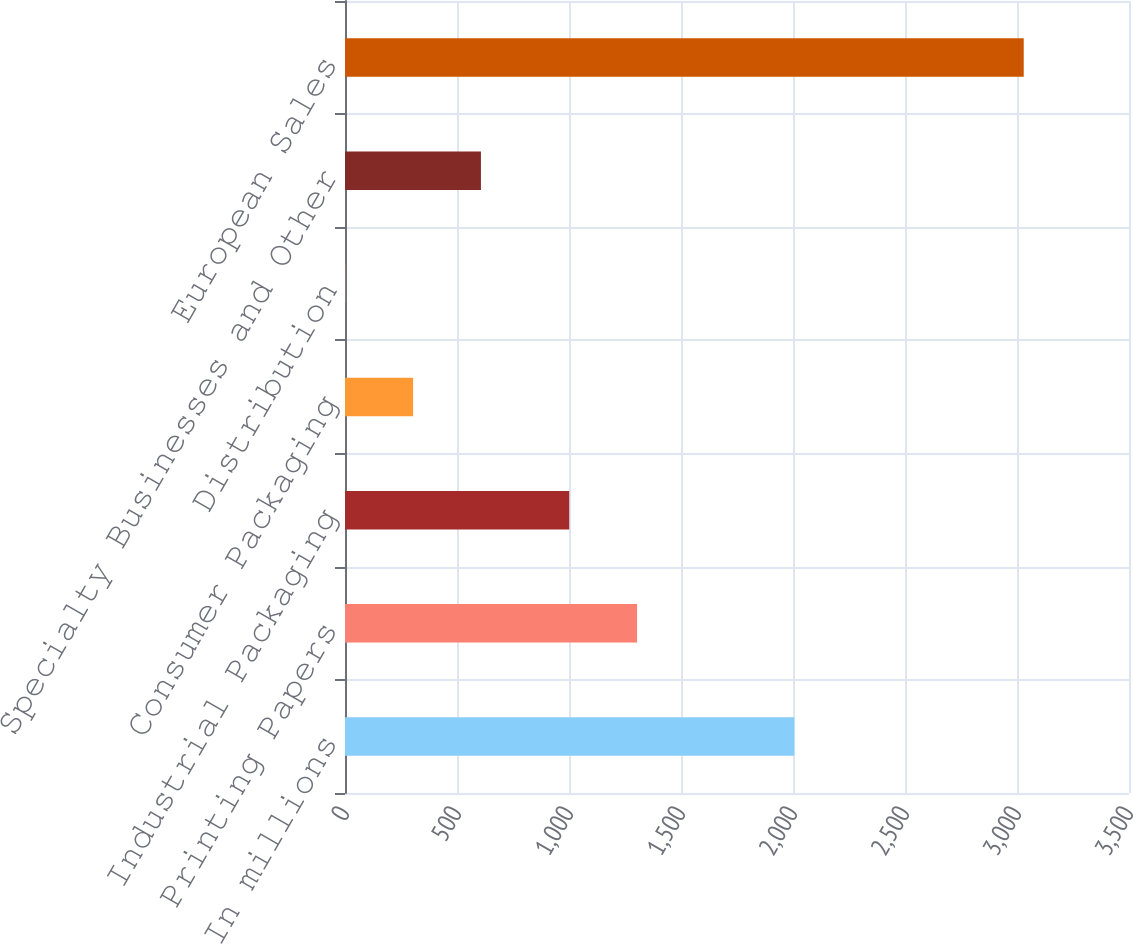Convert chart to OTSL. <chart><loc_0><loc_0><loc_500><loc_500><bar_chart><fcel>In millions<fcel>Printing Papers<fcel>Industrial Packaging<fcel>Consumer Packaging<fcel>Distribution<fcel>Specialty Businesses and Other<fcel>European Sales<nl><fcel>2006<fcel>1303.9<fcel>1001<fcel>303.9<fcel>1<fcel>606.8<fcel>3030<nl></chart> 